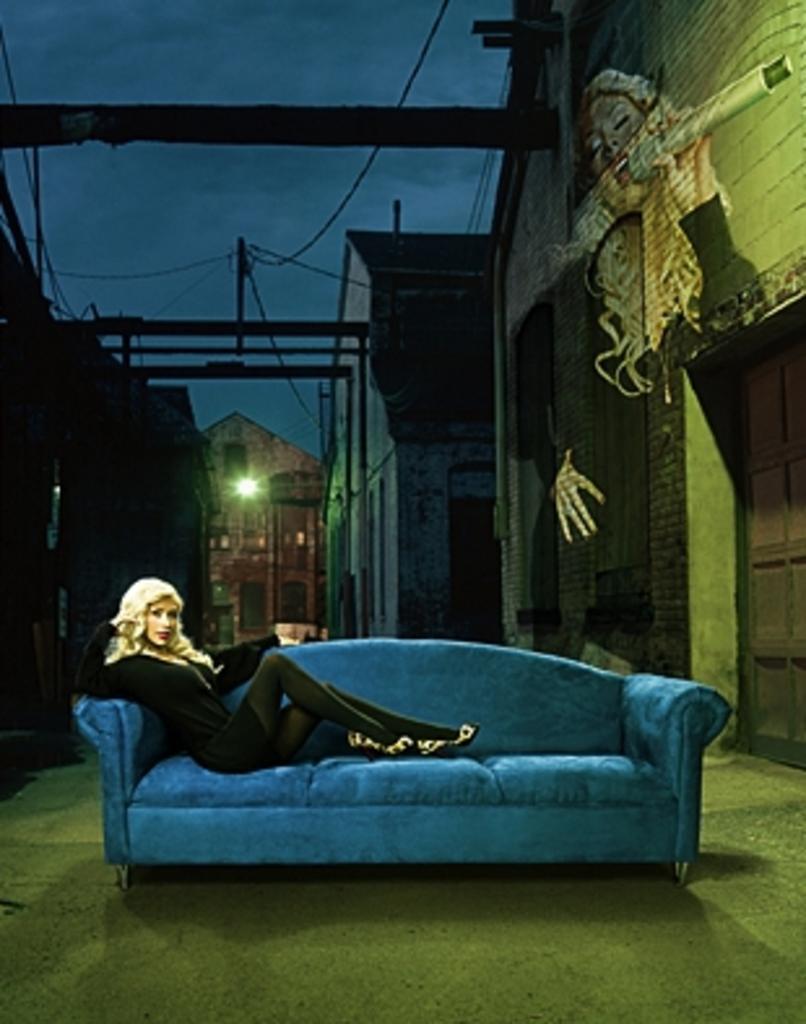Please provide a concise description of this image. This image consists of a sofa and a person sitting on it. She is wearing black dress. There are buildings on right side and left side of the image. There is Sky on the top. There are wires on the top. There is light in the middle. The sofa is in blue color. 